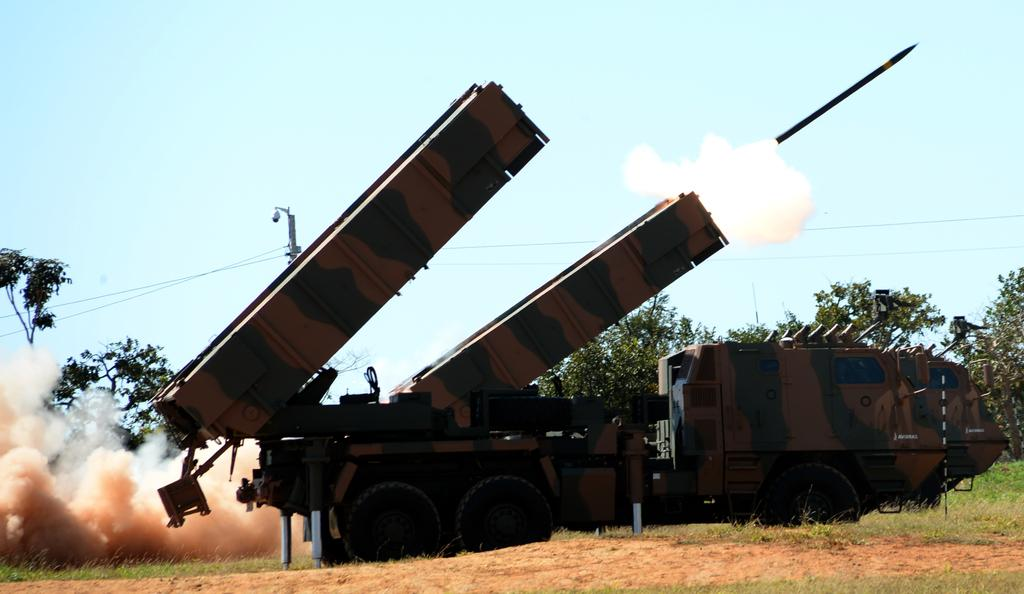What is the main subject in the foreground of the image? There is an artillery tractor in the foreground of the image. What is the position of the artillery tractor in the image? The artillery tractor is on the ground. What can be seen in the image that indicates some activity has taken place? There is smoke visible in the image. What type of natural environment is present in the image? There are trees in the image. What structure can be seen in the image? There is a pole in the image. What is attached to the pole? Cables are present in the image. What part of the natural environment is visible in the image? The sky is visible in the image. What is happening in the air in the image? A bullet is in the air in the image. What is the price of the artillery tractor in the image? The price of the artillery tractor is not visible in the image, and therefore cannot be determined. 